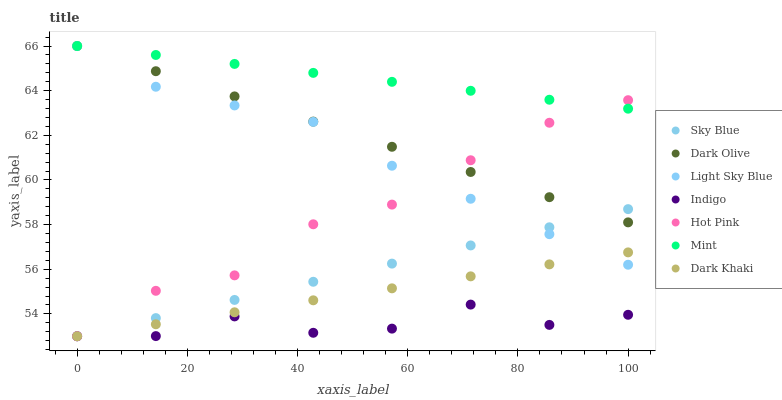Does Indigo have the minimum area under the curve?
Answer yes or no. Yes. Does Mint have the maximum area under the curve?
Answer yes or no. Yes. Does Dark Olive have the minimum area under the curve?
Answer yes or no. No. Does Dark Olive have the maximum area under the curve?
Answer yes or no. No. Is Sky Blue the smoothest?
Answer yes or no. Yes. Is Indigo the roughest?
Answer yes or no. Yes. Is Dark Olive the smoothest?
Answer yes or no. No. Is Dark Olive the roughest?
Answer yes or no. No. Does Hot Pink have the lowest value?
Answer yes or no. Yes. Does Dark Olive have the lowest value?
Answer yes or no. No. Does Mint have the highest value?
Answer yes or no. Yes. Does Indigo have the highest value?
Answer yes or no. No. Is Indigo less than Light Sky Blue?
Answer yes or no. Yes. Is Dark Olive greater than Dark Khaki?
Answer yes or no. Yes. Does Light Sky Blue intersect Dark Olive?
Answer yes or no. Yes. Is Light Sky Blue less than Dark Olive?
Answer yes or no. No. Is Light Sky Blue greater than Dark Olive?
Answer yes or no. No. Does Indigo intersect Light Sky Blue?
Answer yes or no. No. 